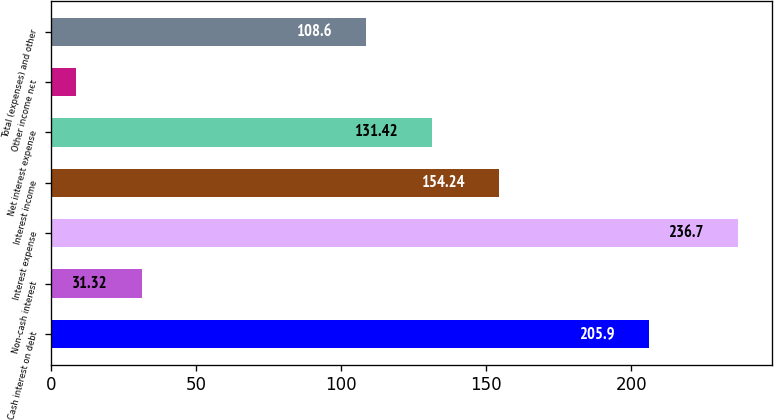<chart> <loc_0><loc_0><loc_500><loc_500><bar_chart><fcel>Cash interest on debt<fcel>Non-cash interest<fcel>Interest expense<fcel>Interest income<fcel>Net interest expense<fcel>Other income net<fcel>Total (expenses) and other<nl><fcel>205.9<fcel>31.32<fcel>236.7<fcel>154.24<fcel>131.42<fcel>8.5<fcel>108.6<nl></chart> 